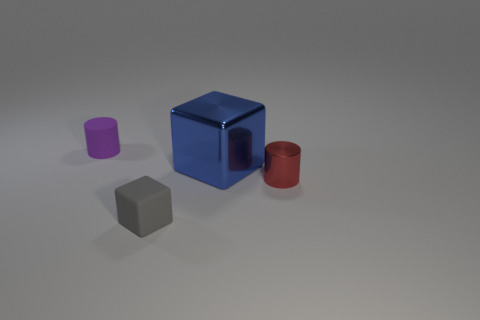If we viewed the objects from above, which shape would be closest to us? If we viewed the scene from above, the small gray cube would be the closest to our viewpoint, with its muted color and simple form standing out from the rest. 